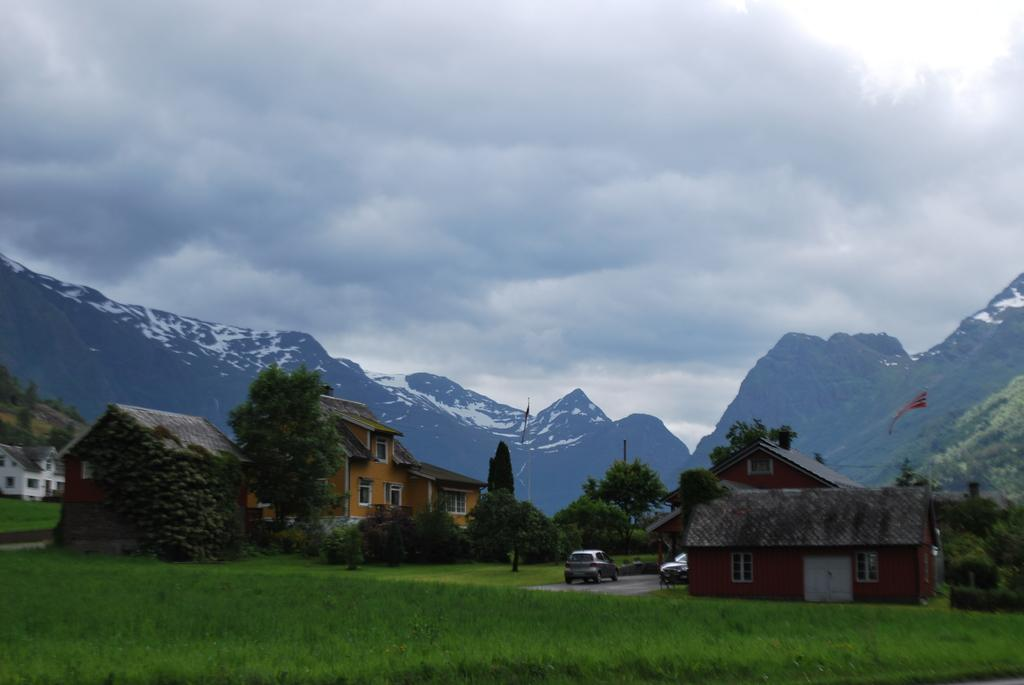What type of vegetation is at the bottom of the image? There is grass at the bottom of the image. What can be seen in the background of the image? There are hills in the background of the image. What type of structures are present in the image? There are houses in the image. What other natural elements can be seen in the image? There are trees in the image. What type of vehicles are visible in the image? There are cars in the image. What is visible at the top of the image? The sky is visible at the top of the image. What is the purpose of the creature in the image? There is no creature present in the image. Can you tell me who the person in the image is talking to? There is no person talking to anyone in the image. 